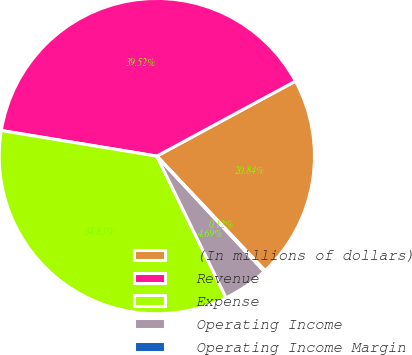Convert chart to OTSL. <chart><loc_0><loc_0><loc_500><loc_500><pie_chart><fcel>(In millions of dollars)<fcel>Revenue<fcel>Expense<fcel>Operating Income<fcel>Operating Income Margin<nl><fcel>20.84%<fcel>39.52%<fcel>34.83%<fcel>4.69%<fcel>0.12%<nl></chart> 